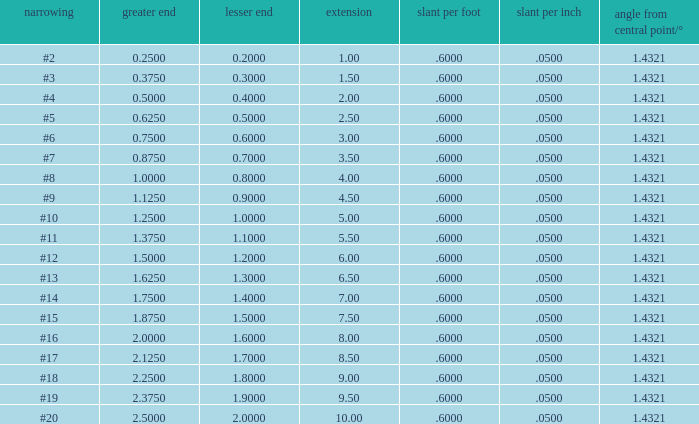Which Length has a Taper of #15, and a Large end larger than 1.875? None. 